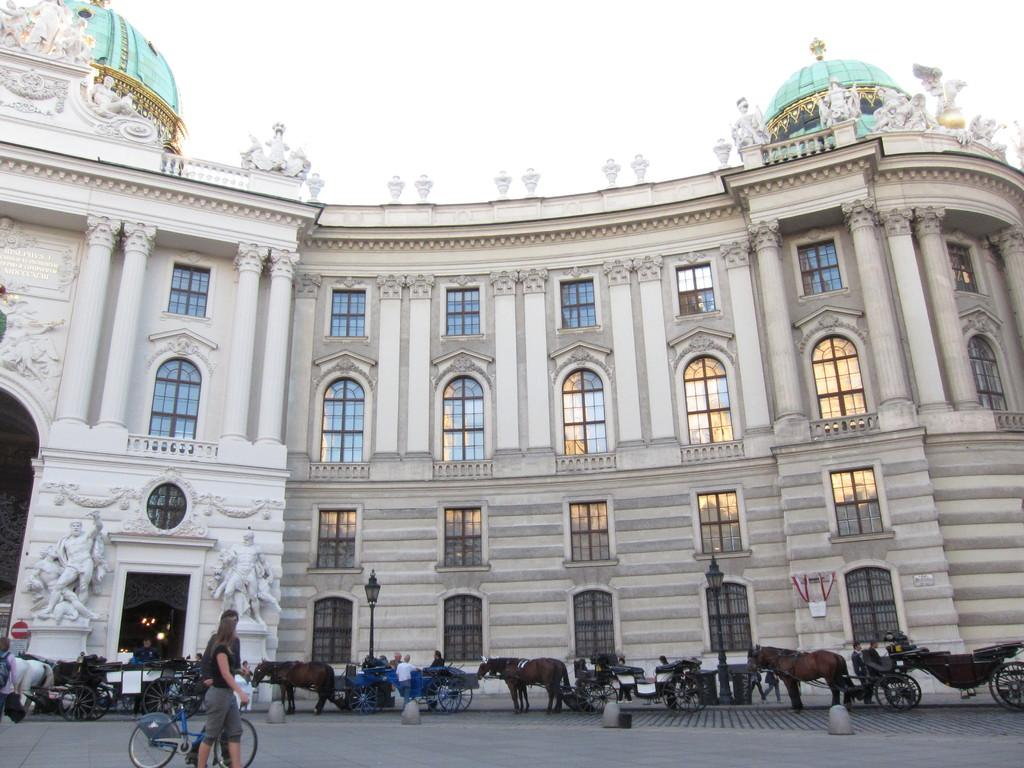Who or what can be seen in the image? There are people in the image. What mode of transportation is present in the image? There is a bicycle and horse carts in the image. What can be seen in the background of the image? There is a building with windows in the background of the image. What is visible at the top of the image? The sky is visible at the top of the image. What type of vest is the minister wearing in the image? There is no minister or vest present in the image. 